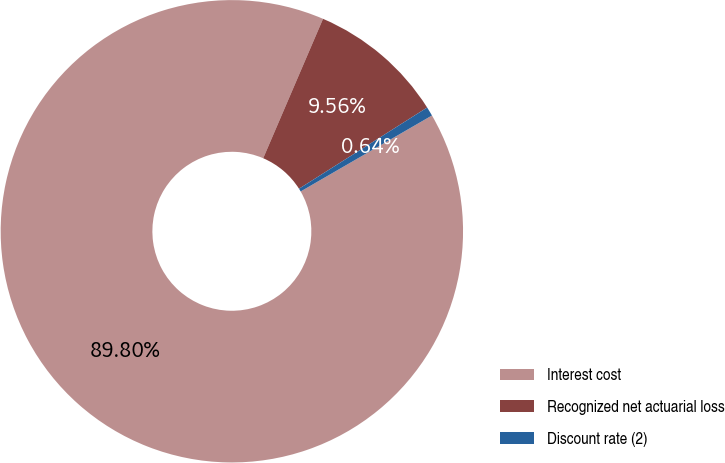Convert chart to OTSL. <chart><loc_0><loc_0><loc_500><loc_500><pie_chart><fcel>Interest cost<fcel>Recognized net actuarial loss<fcel>Discount rate (2)<nl><fcel>89.8%<fcel>9.56%<fcel>0.64%<nl></chart> 